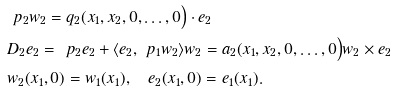Convert formula to latex. <formula><loc_0><loc_0><loc_500><loc_500>& \ p _ { 2 } w _ { 2 } = q _ { 2 } ( x _ { 1 } , x _ { 2 } , 0 , \dots , 0 \Big ) \cdot e _ { 2 } \\ & D _ { 2 } e _ { 2 } = \ p _ { 2 } e _ { 2 } + \langle e _ { 2 } , \ p _ { 1 } w _ { 2 } \rangle w _ { 2 } = a _ { 2 } ( x _ { 1 } , x _ { 2 } , 0 , \dots , 0 \Big ) w _ { 2 } \times e _ { 2 } \\ & w _ { 2 } ( x _ { 1 } , 0 ) = w _ { 1 } ( x _ { 1 } ) , \quad e _ { 2 } ( x _ { 1 } , 0 ) = e _ { 1 } ( x _ { 1 } ) .</formula> 